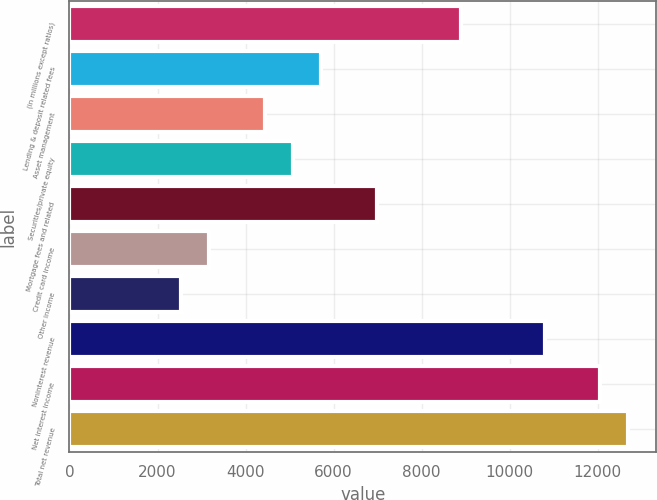<chart> <loc_0><loc_0><loc_500><loc_500><bar_chart><fcel>(in millions except ratios)<fcel>Lending & deposit related fees<fcel>Asset management<fcel>Securities/private equity<fcel>Mortgage fees and related<fcel>Credit card income<fcel>Other income<fcel>Noninterest revenue<fcel>Net interest income<fcel>Total net revenue<nl><fcel>8886.68<fcel>5713.32<fcel>4443.98<fcel>5078.65<fcel>6982.66<fcel>3174.62<fcel>2539.95<fcel>10790.7<fcel>12060<fcel>12694.7<nl></chart> 